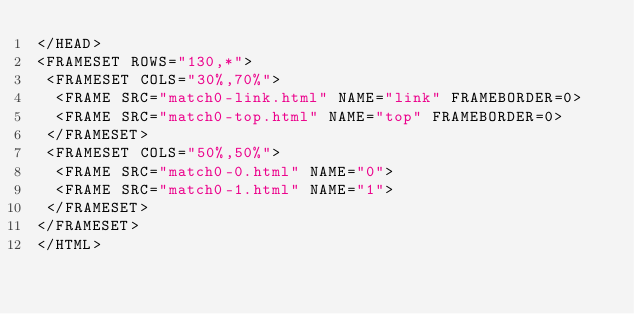Convert code to text. <code><loc_0><loc_0><loc_500><loc_500><_HTML_></HEAD>
<FRAMESET ROWS="130,*">
 <FRAMESET COLS="30%,70%">
  <FRAME SRC="match0-link.html" NAME="link" FRAMEBORDER=0>
  <FRAME SRC="match0-top.html" NAME="top" FRAMEBORDER=0>
 </FRAMESET>
 <FRAMESET COLS="50%,50%">
  <FRAME SRC="match0-0.html" NAME="0">
  <FRAME SRC="match0-1.html" NAME="1">
 </FRAMESET>
</FRAMESET>
</HTML>
</code> 